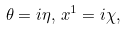Convert formula to latex. <formula><loc_0><loc_0><loc_500><loc_500>\theta = i \eta , \, x ^ { 1 } = i \chi ,</formula> 